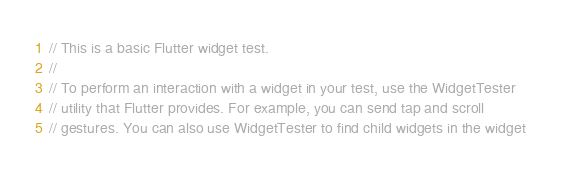Convert code to text. <code><loc_0><loc_0><loc_500><loc_500><_Dart_>// This is a basic Flutter widget test.
//
// To perform an interaction with a widget in your test, use the WidgetTester
// utility that Flutter provides. For example, you can send tap and scroll
// gestures. You can also use WidgetTester to find child widgets in the widget</code> 